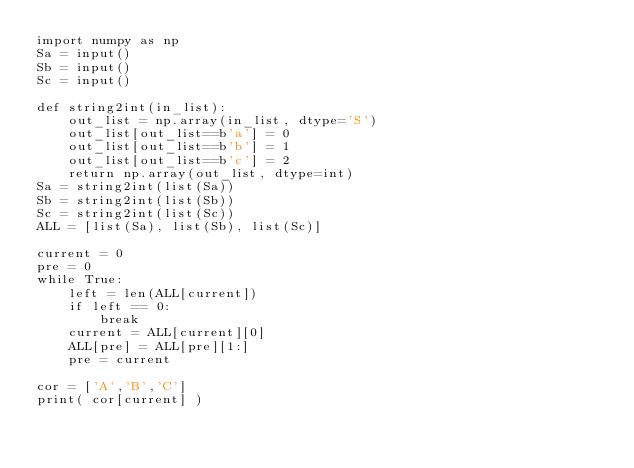Convert code to text. <code><loc_0><loc_0><loc_500><loc_500><_Python_>import numpy as np
Sa = input()
Sb = input()
Sc = input()

def string2int(in_list):
    out_list = np.array(in_list, dtype='S')
    out_list[out_list==b'a'] = 0
    out_list[out_list==b'b'] = 1
    out_list[out_list==b'c'] = 2
    return np.array(out_list, dtype=int)
Sa = string2int(list(Sa))
Sb = string2int(list(Sb))
Sc = string2int(list(Sc))
ALL = [list(Sa), list(Sb), list(Sc)]

current = 0
pre = 0
while True:
    left = len(ALL[current])
    if left == 0:
        break
    current = ALL[current][0]
    ALL[pre] = ALL[pre][1:]
    pre = current

cor = ['A','B','C']
print( cor[current] )</code> 